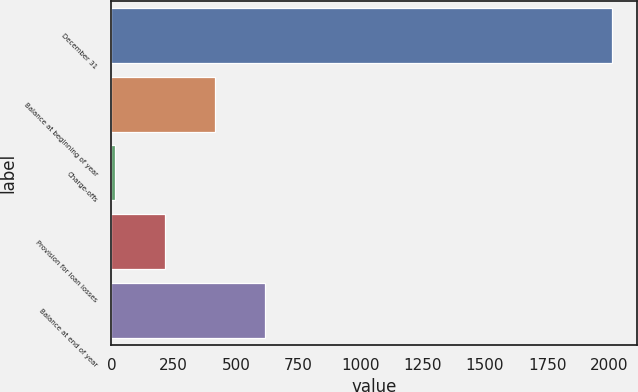Convert chart. <chart><loc_0><loc_0><loc_500><loc_500><bar_chart><fcel>December 31<fcel>Balance at beginning of year<fcel>Charge-offs<fcel>Provision for loan losses<fcel>Balance at end of year<nl><fcel>2012<fcel>415.2<fcel>16<fcel>215.6<fcel>614.8<nl></chart> 